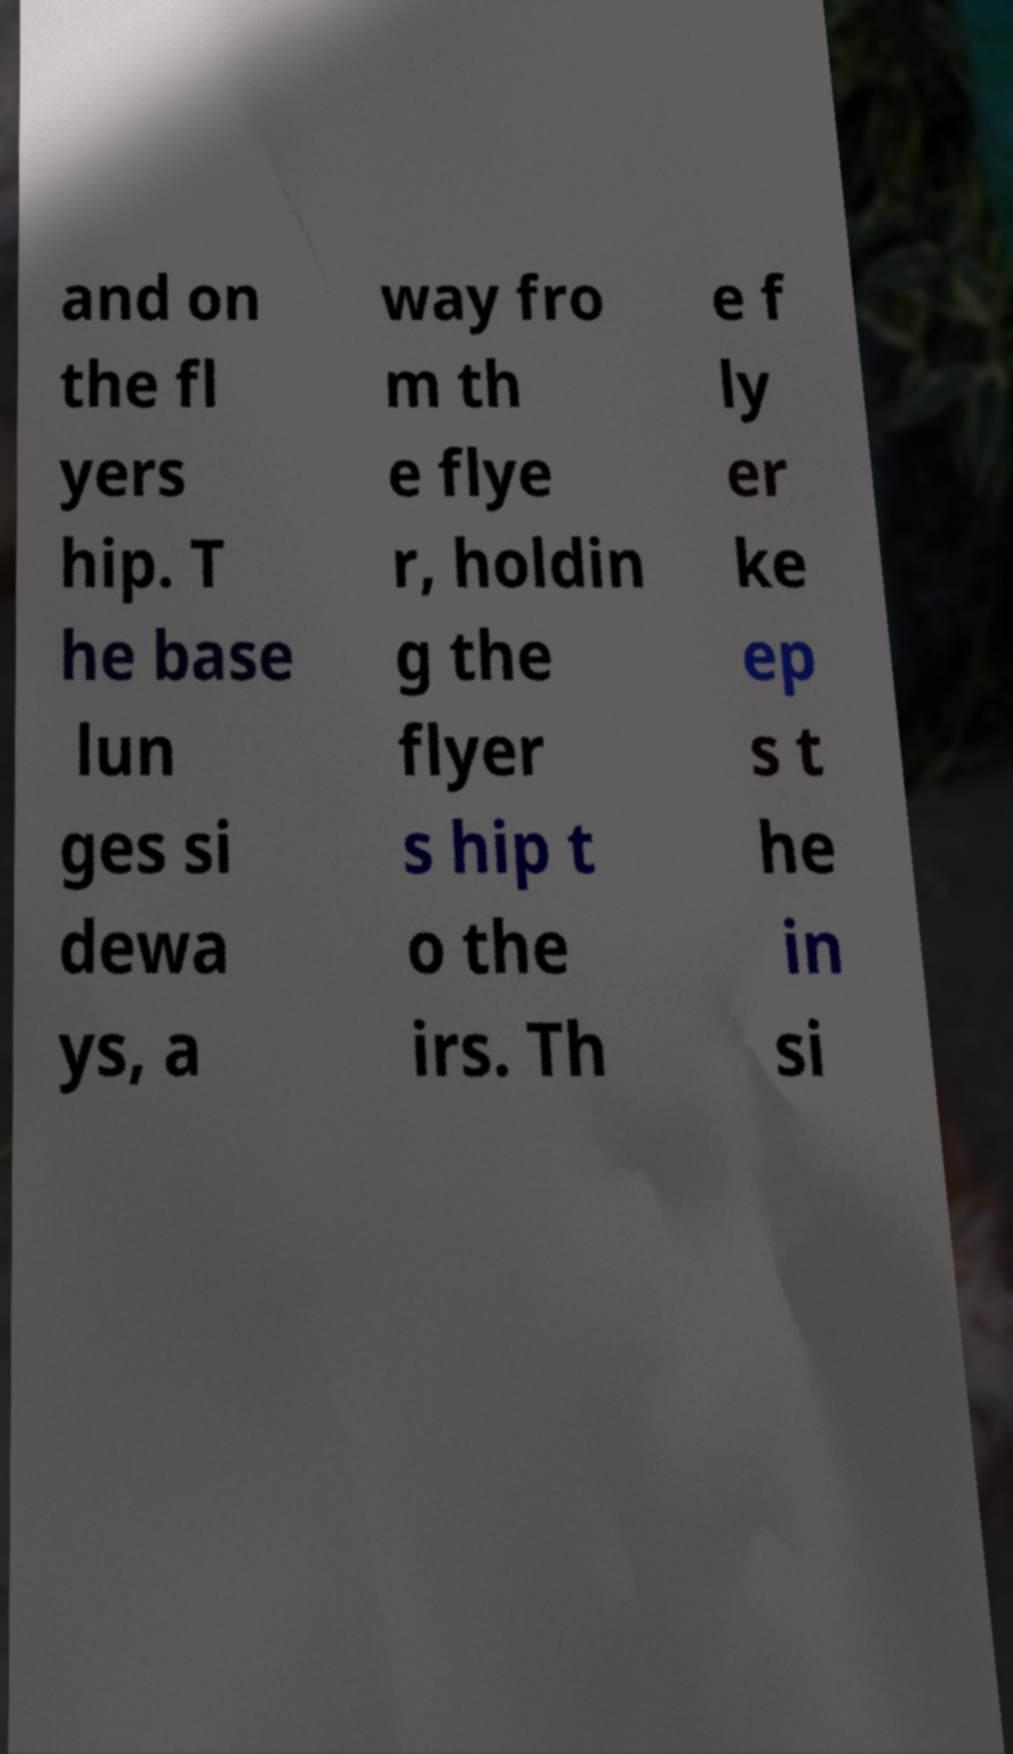Could you assist in decoding the text presented in this image and type it out clearly? and on the fl yers hip. T he base lun ges si dewa ys, a way fro m th e flye r, holdin g the flyer s hip t o the irs. Th e f ly er ke ep s t he in si 